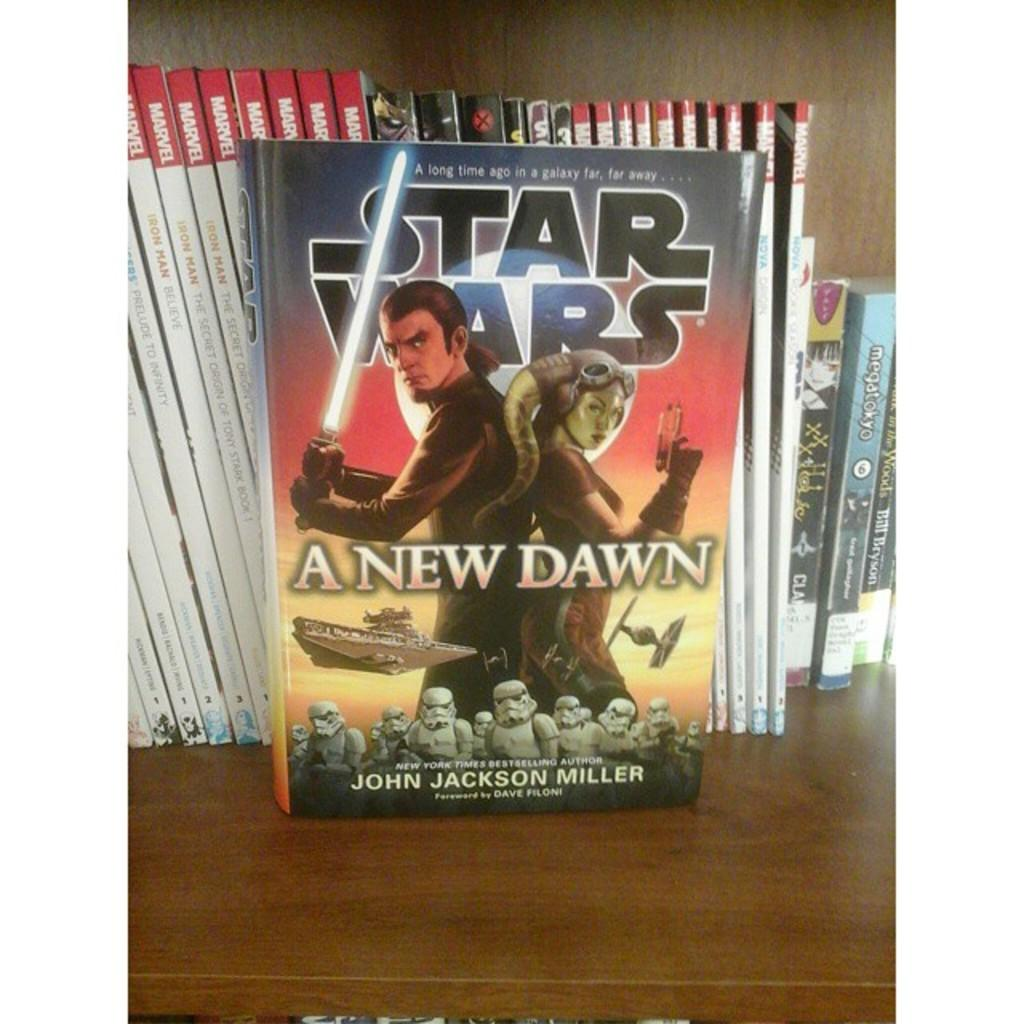Provide a one-sentence caption for the provided image. Star Wars a New Dawn, by John Jackson Miller, is sitting in front of other comics. 